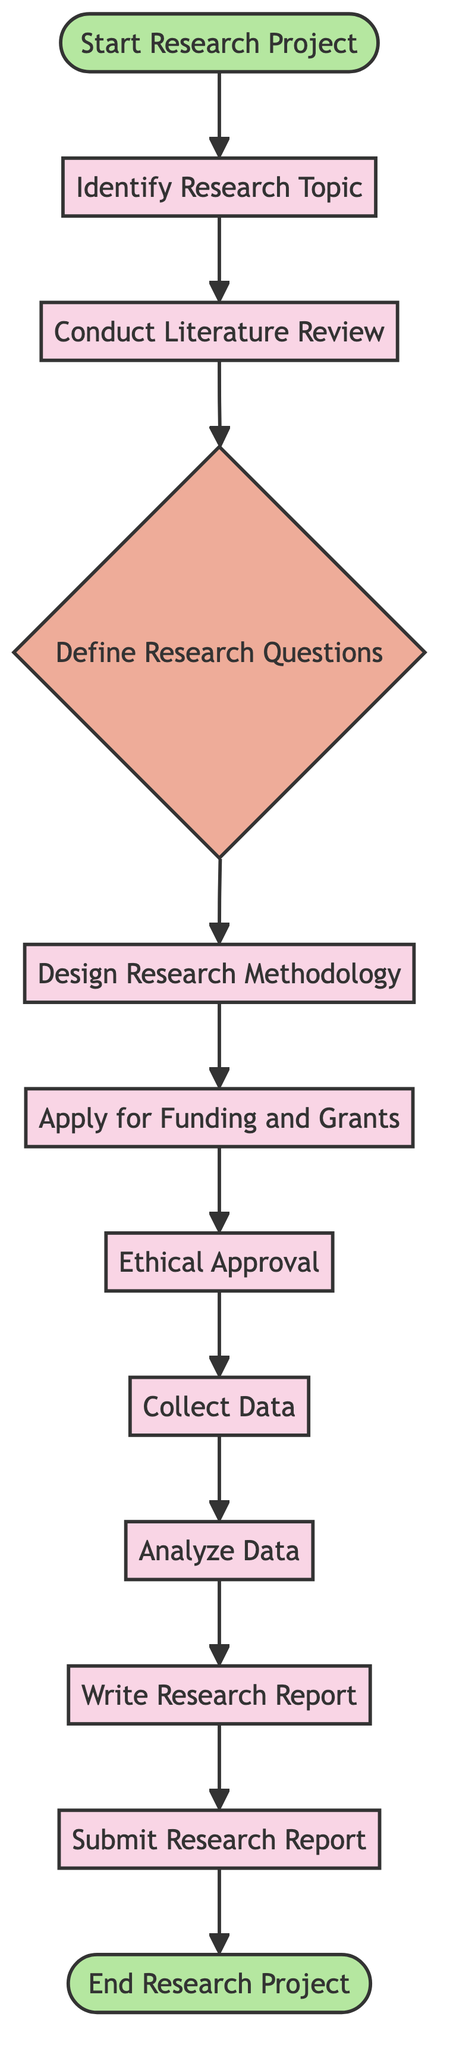What is the first action listed in the diagram? The diagram begins with the "Start Research Project" node, followed by the action node "Identify Research Topic."
Answer: Identify Research Topic How many actions are there in total in the diagram? The diagram includes a total of 8 action nodes: Identify Research Topic, Conduct Literature Review, Design Research Methodology, Apply for Funding and Grants, Ethical Approval, Collect Data, Analyze Data, Write Research Report, and Submit Research Report.
Answer: 8 What comes after collecting data in the process? According to the flow of the diagram, after the action "Collect Data," the next step is the action "Analyze Data."
Answer: Analyze Data What is the final node of the diagram? The last node in the activity diagram is labeled as "End Research Project," indicating the conclusion of the research process.
Answer: End Research Project Which action requires approval before proceeding to collect data? The diagram indicates that "Ethical Approval" is required before moving on to the "Collect Data" action.
Answer: Ethical Approval What type of node is "Define Research Questions"? The node "Define Research Questions" is classified as a decision node, indicating a point in the process where specific questions or hypotheses need to be formulated.
Answer: Decision Node Is there a step where funding applications are submitted? Yes, the action "Apply for Funding and Grants" represents the step where applications to scholarship programs and research grants are submitted.
Answer: Apply for Funding and Grants What is the relationship between conducting a literature review and defining research questions? The action "Conduct Literature Review" precedes the decision node "Define Research Questions," meaning that after reviewing existing studies, researchers will formulate their specific research questions.
Answer: Conduct Literature Review → Define Research Questions What is the second action after defining research questions? After reaching the decision node "Define Research Questions," the next step is "Design Research Methodology."
Answer: Design Research Methodology 